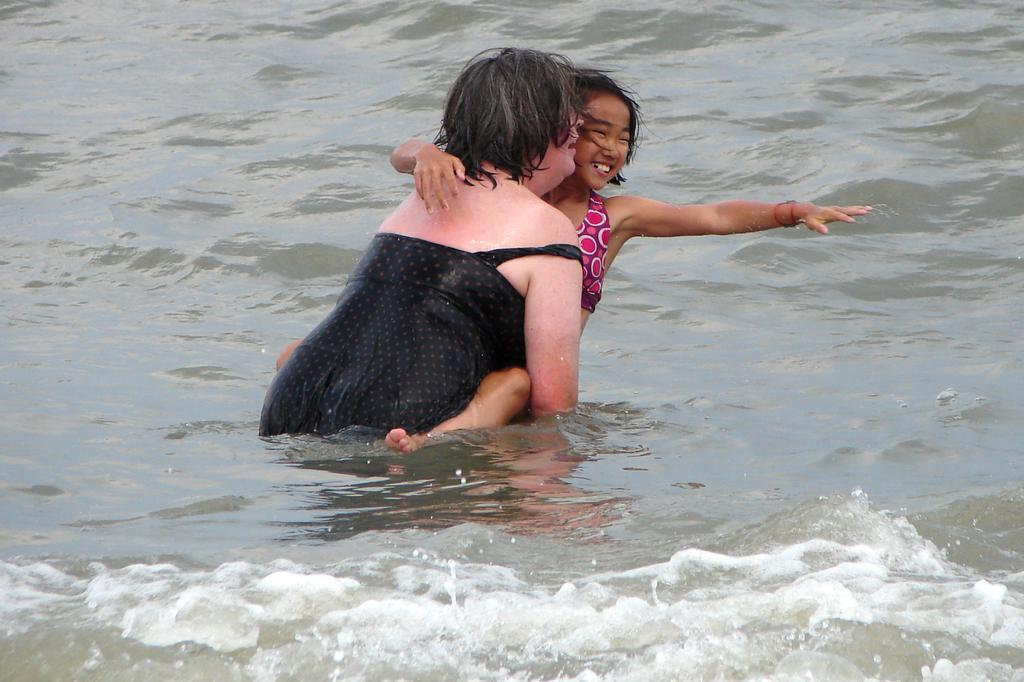What is visible in the image? There is water visible in the image. Are there any living beings present in the image? Yes, there are people in the image. What type of fiction is being read by the animal in the image? There is no animal present in the image, and therefore no such activity can be observed. 